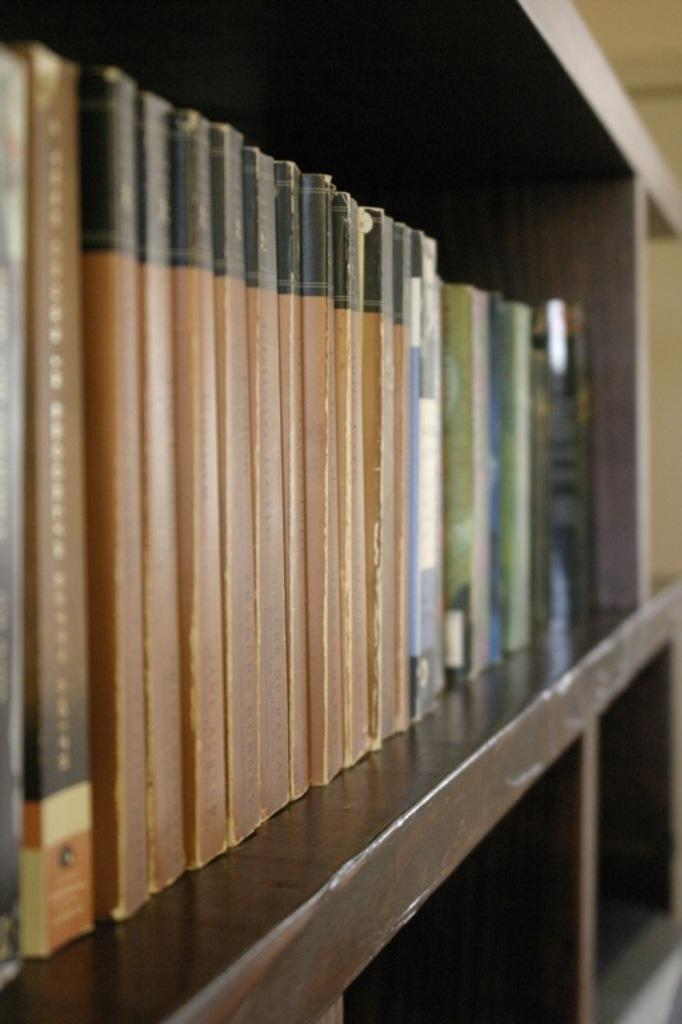What is the main subject of the image? The main subject of the image is many books. Where are the books located in the image? The books are in a rack. What type of haircut is the book receiving in the image? There is no haircut present in the image, as the subject is books and not a person. 